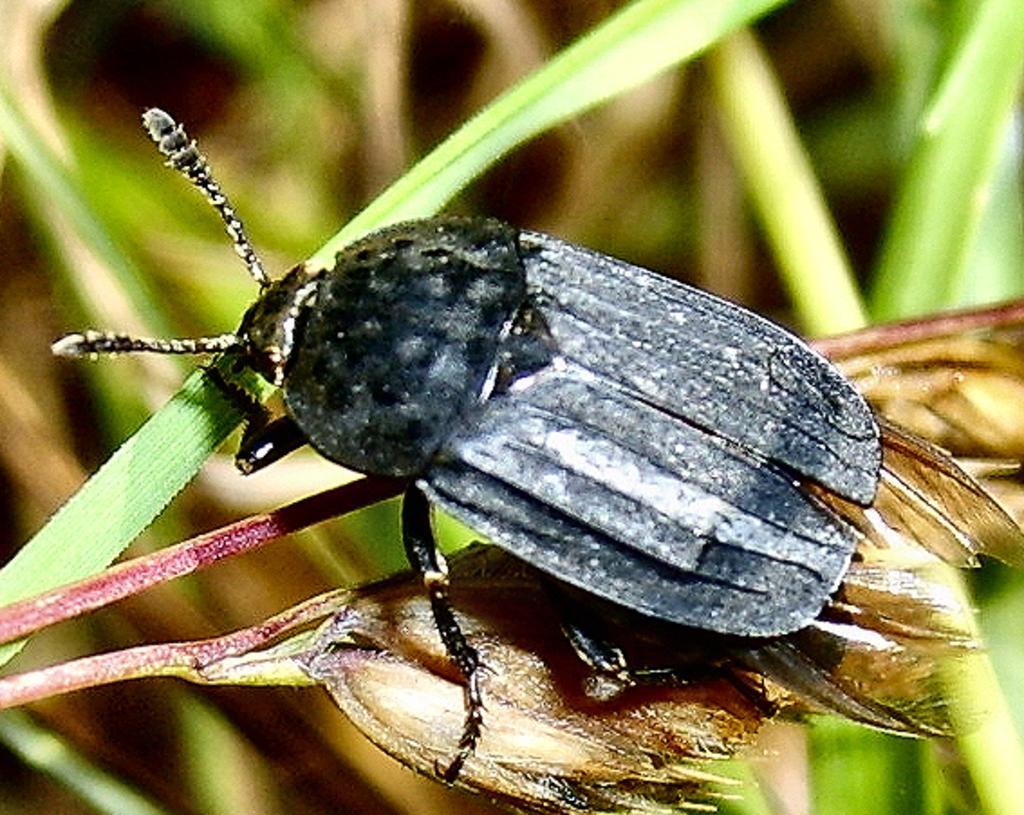Please provide a concise description of this image. In this image we can see an insect on the plant. The background of the image is blurred. 